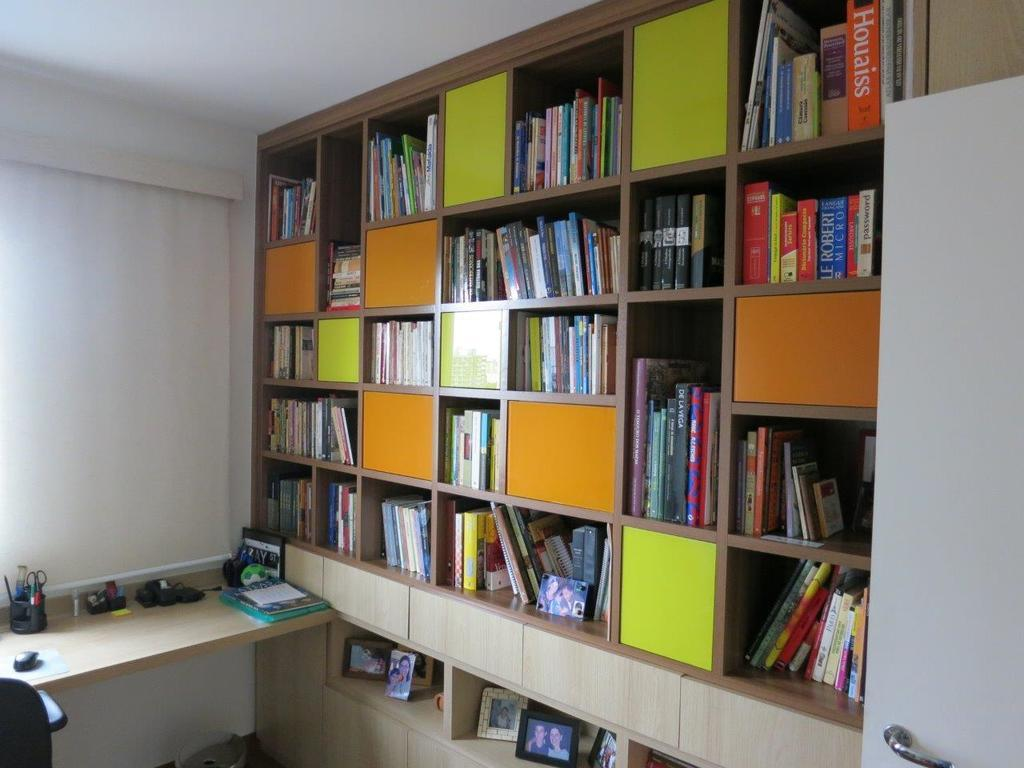Provide a one-sentence caption for the provided image. A large, built in bookshelf with various size sections contains photographs and books, including the titles "Password", "De La Viga", and "Houaiss". 